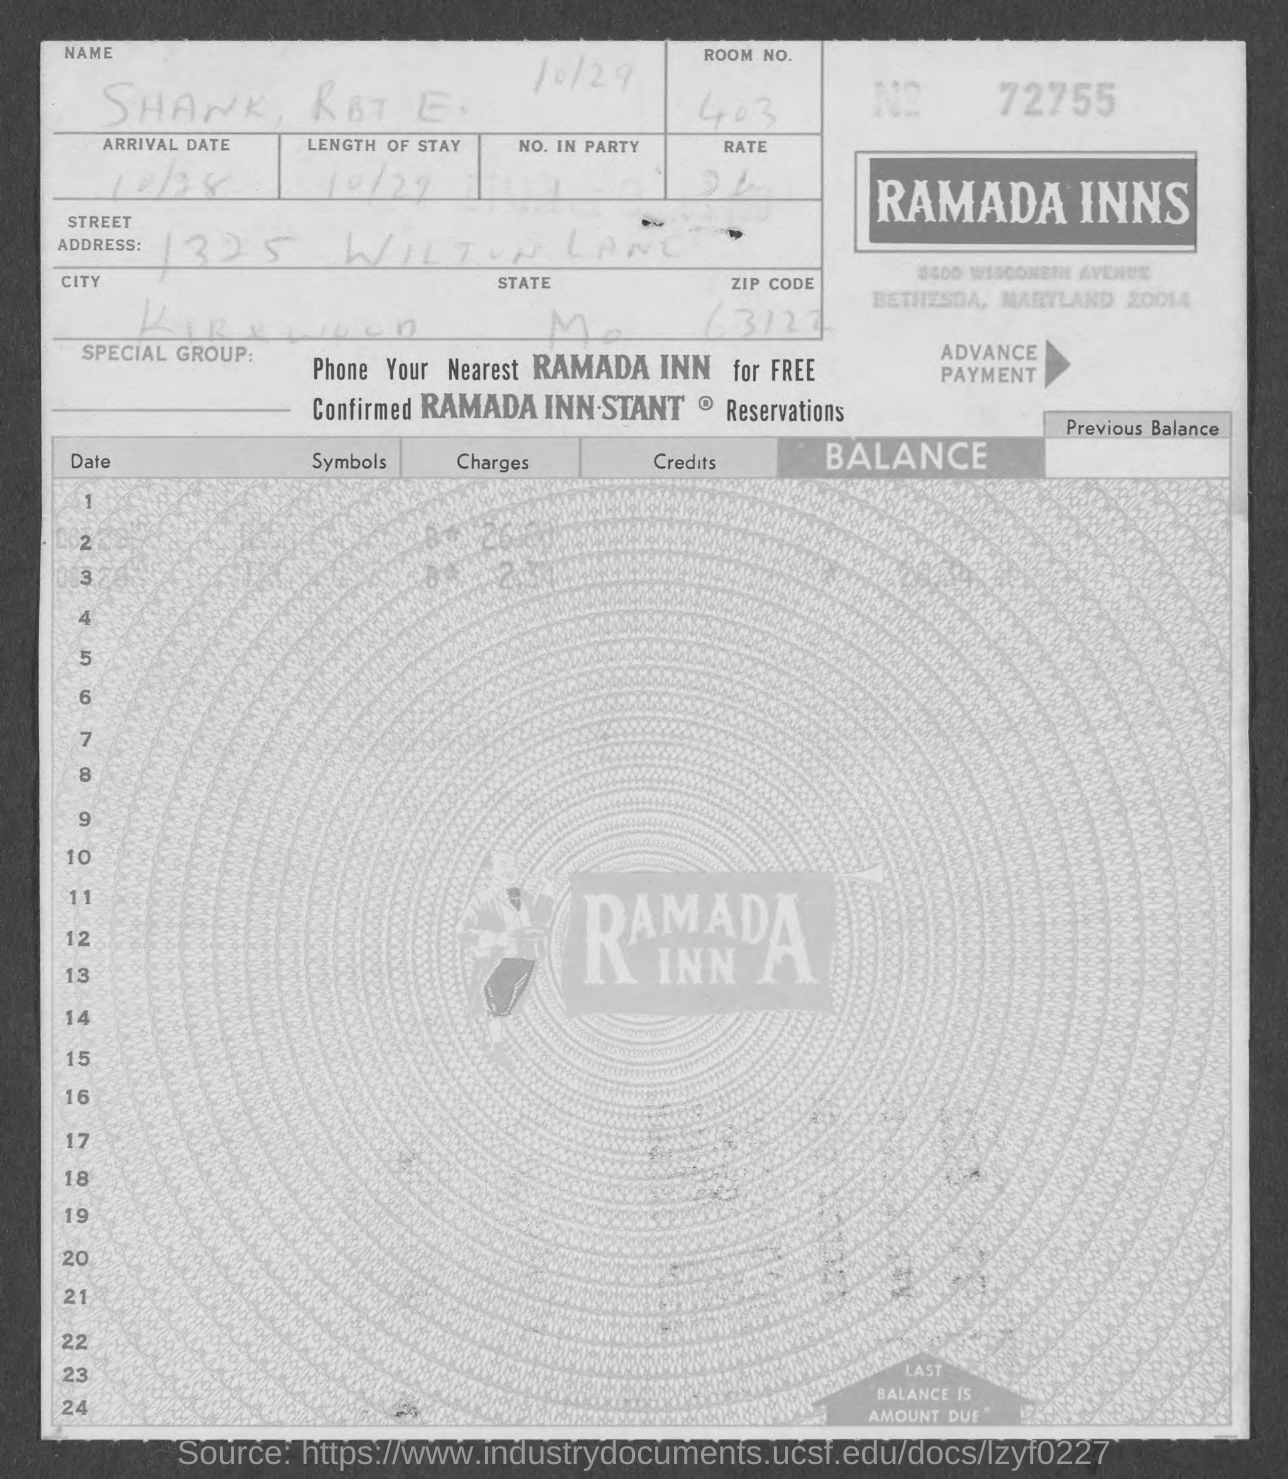Draw attention to some important aspects in this diagram. The invoice number is 72755... 